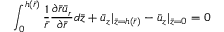<formula> <loc_0><loc_0><loc_500><loc_500>\int _ { 0 } ^ { h ( \bar { r } ) } \frac { 1 } { \bar { r } } \frac { { \partial } \bar { r } { \bar { u } } _ { r } } { \partial { \bar { r } } } d \bar { z } + { \bar { u } } _ { z } | _ { \bar { z } = h ( \bar { r } ) } - { \bar { u } } _ { z } | _ { \bar { z } = 0 } = 0</formula> 